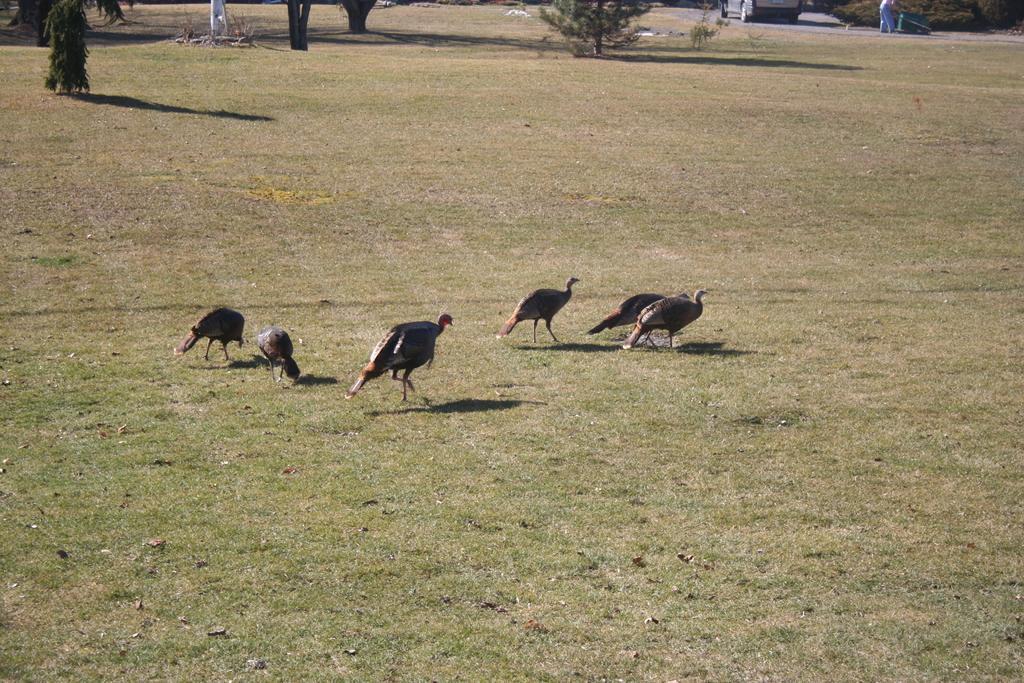How would you summarize this image in a sentence or two? In this picture, these look like birds standing on the grass field surrounded by trees. 